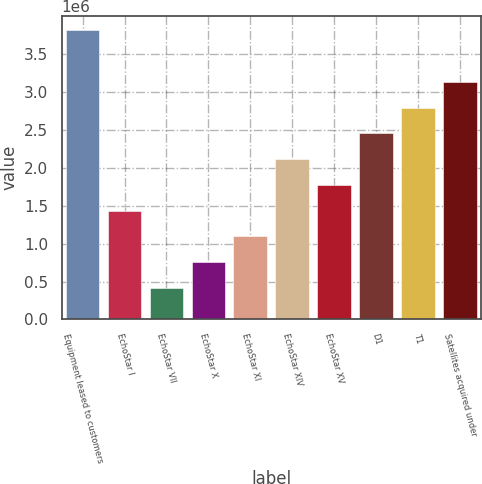Convert chart to OTSL. <chart><loc_0><loc_0><loc_500><loc_500><bar_chart><fcel>Equipment leased to customers<fcel>EchoStar I<fcel>EchoStar VII<fcel>EchoStar X<fcel>EchoStar XI<fcel>EchoStar XIV<fcel>EchoStar XV<fcel>D1<fcel>T1<fcel>Satellites acquired under<nl><fcel>3.80575e+06<fcel>1.43474e+06<fcel>418585<fcel>757302<fcel>1.09602e+06<fcel>2.11217e+06<fcel>1.77345e+06<fcel>2.45089e+06<fcel>2.7896e+06<fcel>3.12832e+06<nl></chart> 